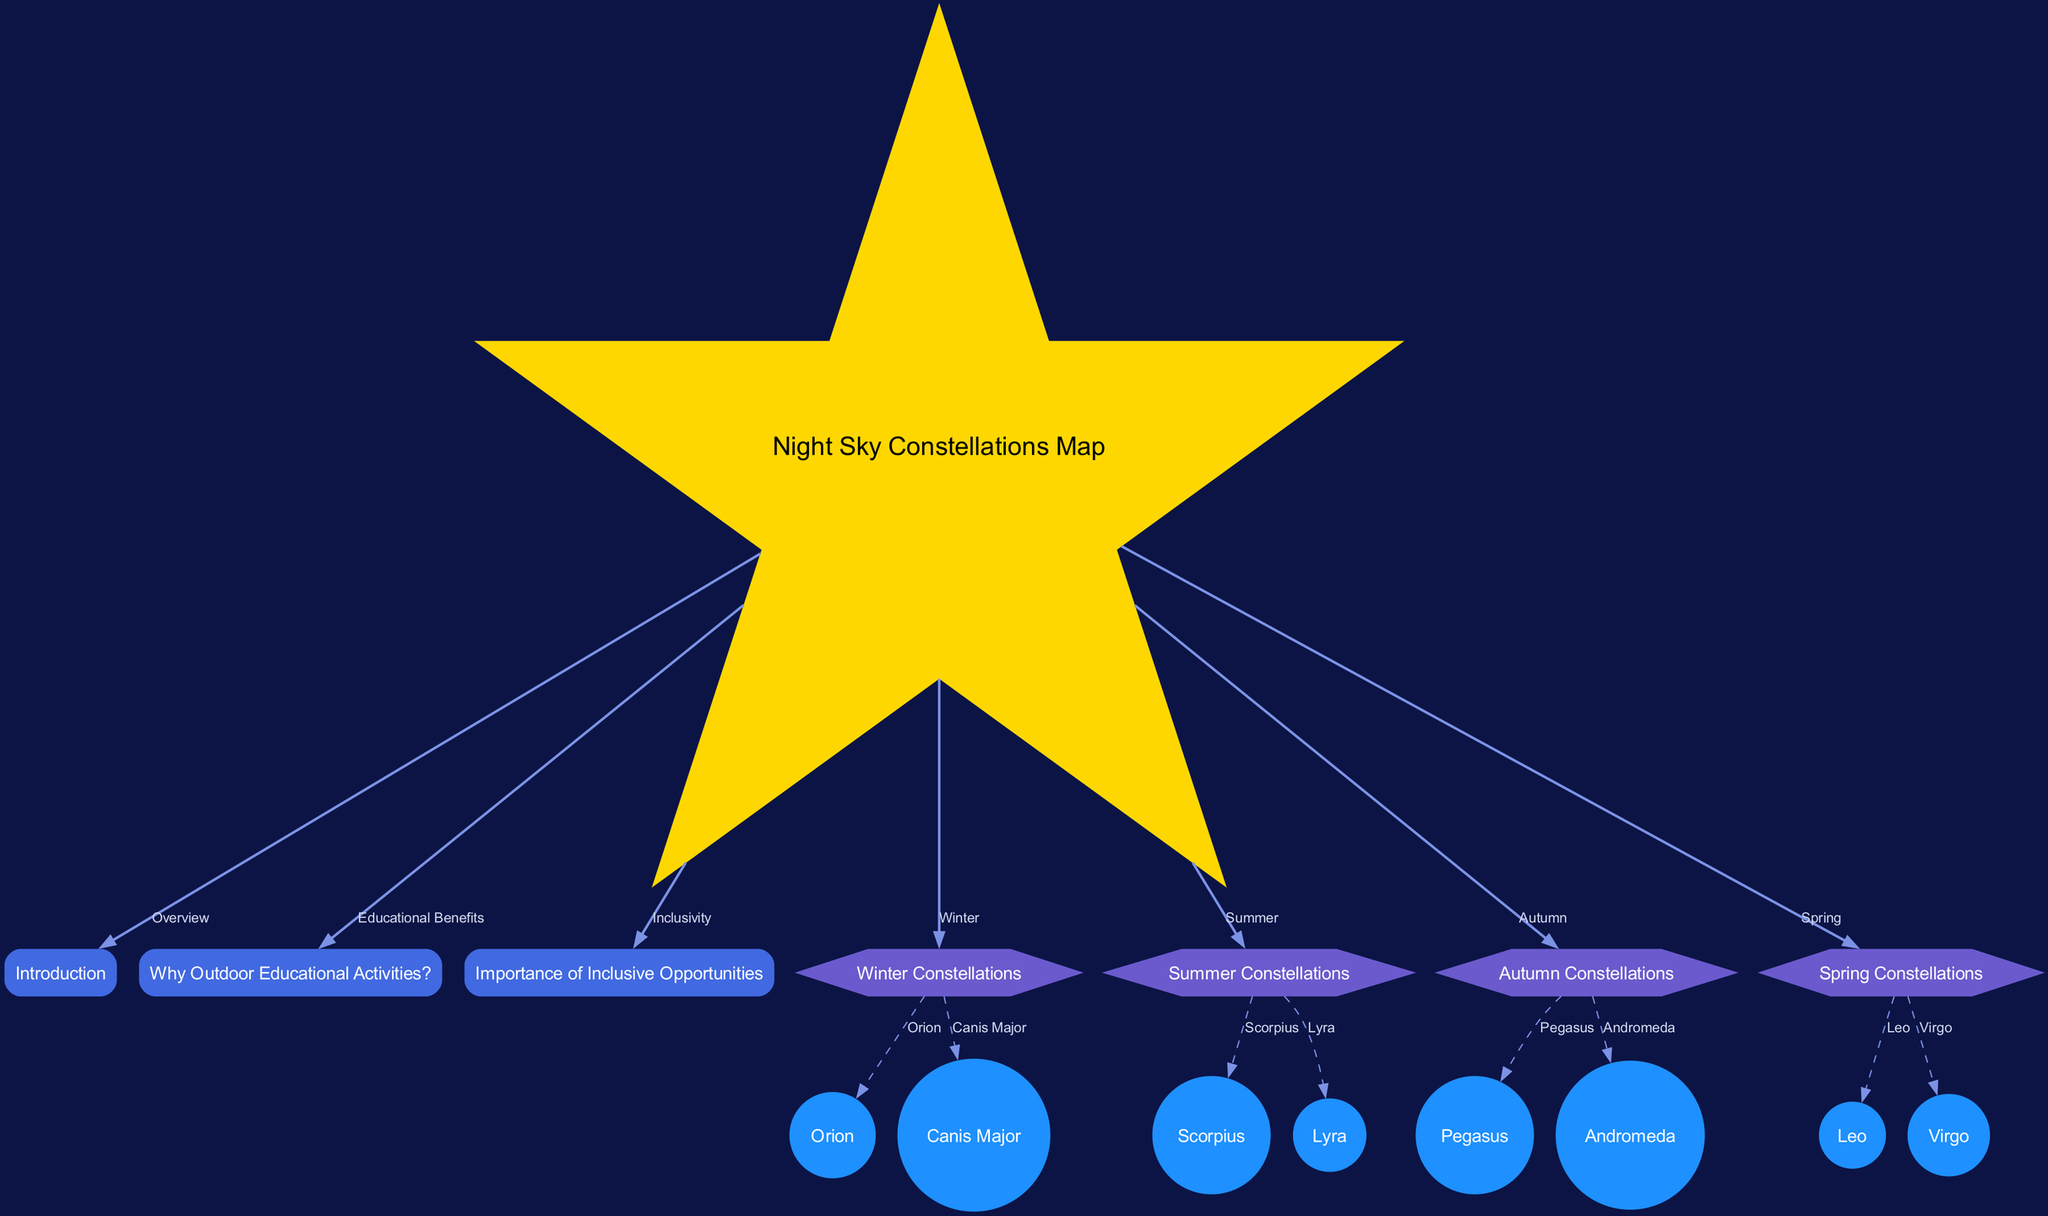What is the main subject of the diagram? The diagram is titled "Night Sky Constellations Map," indicating that its primary focus is on mapping the constellations visible in the night sky during different seasons
Answer: Night Sky Constellations Map How many seasons are represented in the diagram? The diagram shows constellations for four seasons: Winter, Summer, Autumn, and Spring, which are directly linked from the main node
Answer: Four Name one constellation visible in Winter. Under the Winter Constellations section, the diagram specifically lists "Orion" and "Canis Major" as examples, thus either can be a valid answer
Answer: Orion What type of benefits are highlighted in the diagram? The edge labeled "Educational Benefits" connects the main node to the section explaining "Why Outdoor Educational Activities?" suggesting that educational benefits are a focus
Answer: Educational Benefits What is one reason why inclusive opportunities are important according to the diagram? The diagram connects to a section highlighting the "Importance of Inclusive Opportunities," but provides no direct reasoning. However, since the central node links to it, it's implied that fostering inclusivity improves educational experiences
Answer: Importance of Inclusive Opportunities Which constellation is associated with Summer? The Summer Constellations section shows "Scorpius" and "Lyra," so either of these constellations fits this description as visible during that season
Answer: Scorpius Name one constellation that belongs to the Spring season. The diagram indicates that "Leo" and "Virgo" are the constellations outlined for Spring, thus either can be correctly noted
Answer: Leo How many constellations are listed under Autumn? The Autumn section of the diagram mentions two constellations: "Pegasus" and "Andromeda," leading to the conclusion that there are two constellations listed for this season
Answer: Two What shape is used for the main node in the diagram? The node representing the "Night Sky Constellations Map" is indicated to be in the shape of a star as per the diagram's description, differentiating it from other shapes used for other categories
Answer: Star 